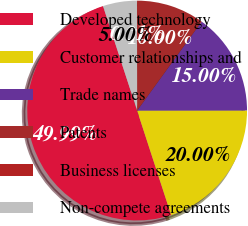<chart> <loc_0><loc_0><loc_500><loc_500><pie_chart><fcel>Developed technology<fcel>Customer relationships and<fcel>Trade names<fcel>Patents<fcel>Business licenses<fcel>Non-compete agreements<nl><fcel>49.99%<fcel>20.0%<fcel>15.0%<fcel>10.0%<fcel>0.01%<fcel>5.0%<nl></chart> 